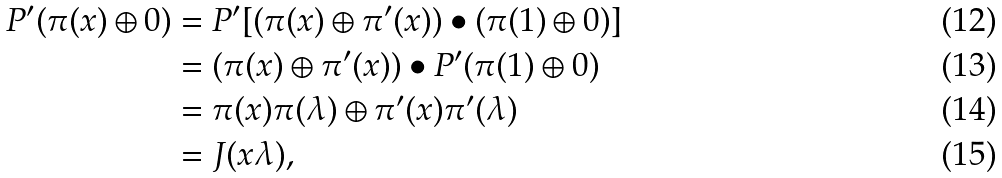<formula> <loc_0><loc_0><loc_500><loc_500>P ^ { \prime } ( \pi ( x ) \oplus 0 ) & = P ^ { \prime } [ ( \pi ( x ) \oplus \pi ^ { \prime } ( x ) ) \bullet ( \pi ( 1 ) \oplus 0 ) ] \\ & = ( \pi ( x ) \oplus \pi ^ { \prime } ( x ) ) \bullet P ^ { \prime } ( \pi ( 1 ) \oplus 0 ) \\ & = \pi ( x ) \pi ( \lambda ) \oplus \pi ^ { \prime } ( x ) \pi ^ { \prime } ( \lambda ) \\ & = J ( x \lambda ) ,</formula> 